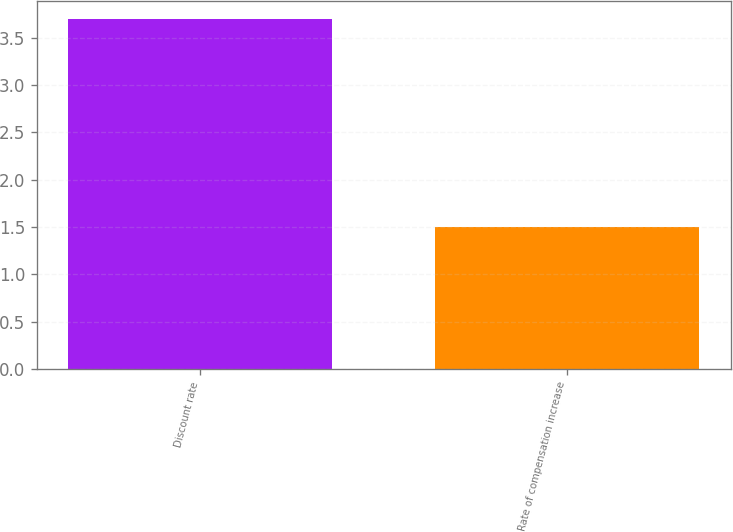Convert chart to OTSL. <chart><loc_0><loc_0><loc_500><loc_500><bar_chart><fcel>Discount rate<fcel>Rate of compensation increase<nl><fcel>3.7<fcel>1.5<nl></chart> 